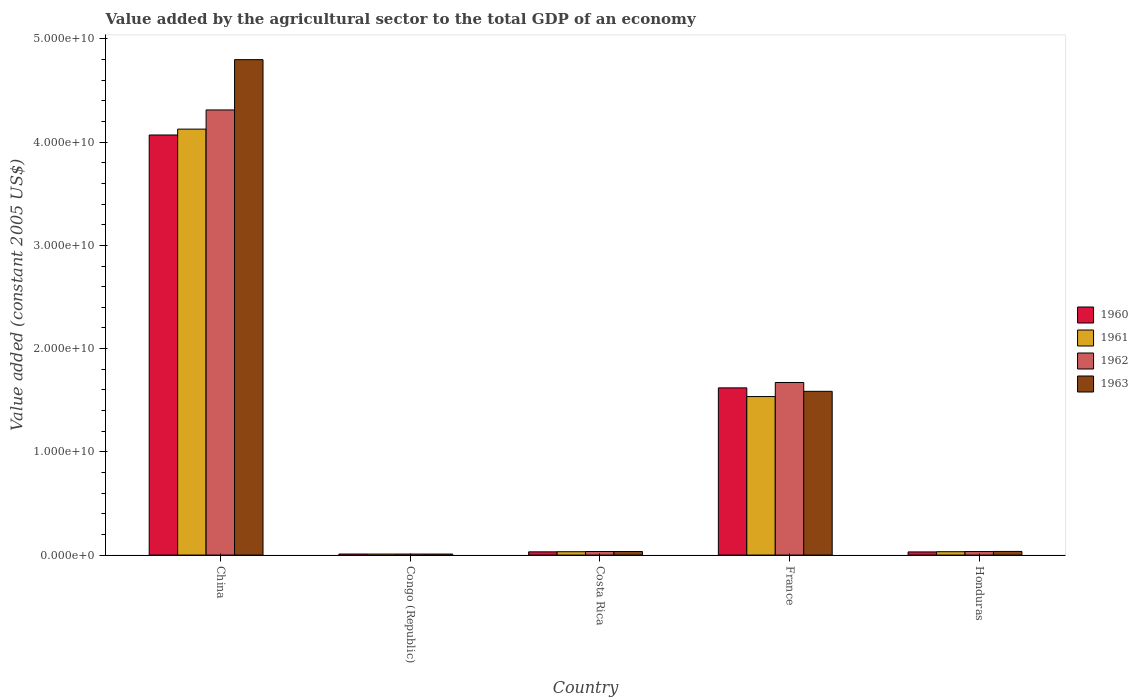How many groups of bars are there?
Offer a very short reply. 5. Are the number of bars per tick equal to the number of legend labels?
Make the answer very short. Yes. How many bars are there on the 1st tick from the left?
Your answer should be very brief. 4. What is the value added by the agricultural sector in 1963 in China?
Make the answer very short. 4.80e+1. Across all countries, what is the maximum value added by the agricultural sector in 1963?
Offer a very short reply. 4.80e+1. Across all countries, what is the minimum value added by the agricultural sector in 1960?
Provide a short and direct response. 1.01e+08. In which country was the value added by the agricultural sector in 1960 maximum?
Offer a terse response. China. In which country was the value added by the agricultural sector in 1960 minimum?
Your answer should be very brief. Congo (Republic). What is the total value added by the agricultural sector in 1961 in the graph?
Provide a short and direct response. 5.74e+1. What is the difference between the value added by the agricultural sector in 1963 in China and that in Honduras?
Your response must be concise. 4.76e+1. What is the difference between the value added by the agricultural sector in 1963 in France and the value added by the agricultural sector in 1960 in China?
Provide a short and direct response. -2.48e+1. What is the average value added by the agricultural sector in 1960 per country?
Your answer should be very brief. 1.15e+1. What is the difference between the value added by the agricultural sector of/in 1963 and value added by the agricultural sector of/in 1962 in Congo (Republic)?
Provide a short and direct response. 6.85e+05. What is the ratio of the value added by the agricultural sector in 1962 in Costa Rica to that in Honduras?
Keep it short and to the point. 1.01. What is the difference between the highest and the second highest value added by the agricultural sector in 1963?
Your answer should be very brief. 4.76e+1. What is the difference between the highest and the lowest value added by the agricultural sector in 1961?
Provide a succinct answer. 4.12e+1. Is it the case that in every country, the sum of the value added by the agricultural sector in 1960 and value added by the agricultural sector in 1963 is greater than the sum of value added by the agricultural sector in 1961 and value added by the agricultural sector in 1962?
Your answer should be very brief. No. What does the 1st bar from the left in Costa Rica represents?
Provide a short and direct response. 1960. How many bars are there?
Offer a terse response. 20. Are all the bars in the graph horizontal?
Your response must be concise. No. How many countries are there in the graph?
Your response must be concise. 5. What is the difference between two consecutive major ticks on the Y-axis?
Offer a terse response. 1.00e+1. Does the graph contain any zero values?
Your answer should be compact. No. Does the graph contain grids?
Ensure brevity in your answer.  No. Where does the legend appear in the graph?
Offer a very short reply. Center right. What is the title of the graph?
Keep it short and to the point. Value added by the agricultural sector to the total GDP of an economy. Does "1978" appear as one of the legend labels in the graph?
Give a very brief answer. No. What is the label or title of the X-axis?
Ensure brevity in your answer.  Country. What is the label or title of the Y-axis?
Offer a terse response. Value added (constant 2005 US$). What is the Value added (constant 2005 US$) in 1960 in China?
Offer a very short reply. 4.07e+1. What is the Value added (constant 2005 US$) of 1961 in China?
Offer a very short reply. 4.13e+1. What is the Value added (constant 2005 US$) in 1962 in China?
Give a very brief answer. 4.31e+1. What is the Value added (constant 2005 US$) of 1963 in China?
Provide a succinct answer. 4.80e+1. What is the Value added (constant 2005 US$) of 1960 in Congo (Republic)?
Your response must be concise. 1.01e+08. What is the Value added (constant 2005 US$) of 1961 in Congo (Republic)?
Give a very brief answer. 9.74e+07. What is the Value added (constant 2005 US$) in 1962 in Congo (Republic)?
Keep it short and to the point. 9.79e+07. What is the Value added (constant 2005 US$) in 1963 in Congo (Republic)?
Your response must be concise. 9.86e+07. What is the Value added (constant 2005 US$) of 1960 in Costa Rica?
Provide a short and direct response. 3.13e+08. What is the Value added (constant 2005 US$) of 1961 in Costa Rica?
Offer a very short reply. 3.24e+08. What is the Value added (constant 2005 US$) of 1962 in Costa Rica?
Provide a succinct answer. 3.44e+08. What is the Value added (constant 2005 US$) of 1963 in Costa Rica?
Offer a terse response. 3.43e+08. What is the Value added (constant 2005 US$) of 1960 in France?
Your answer should be very brief. 1.62e+1. What is the Value added (constant 2005 US$) in 1961 in France?
Provide a succinct answer. 1.54e+1. What is the Value added (constant 2005 US$) in 1962 in France?
Provide a short and direct response. 1.67e+1. What is the Value added (constant 2005 US$) of 1963 in France?
Your response must be concise. 1.59e+1. What is the Value added (constant 2005 US$) of 1960 in Honduras?
Provide a short and direct response. 3.05e+08. What is the Value added (constant 2005 US$) in 1961 in Honduras?
Provide a succinct answer. 3.25e+08. What is the Value added (constant 2005 US$) in 1962 in Honduras?
Provide a succinct answer. 3.41e+08. What is the Value added (constant 2005 US$) in 1963 in Honduras?
Your answer should be compact. 3.53e+08. Across all countries, what is the maximum Value added (constant 2005 US$) in 1960?
Provide a short and direct response. 4.07e+1. Across all countries, what is the maximum Value added (constant 2005 US$) of 1961?
Offer a very short reply. 4.13e+1. Across all countries, what is the maximum Value added (constant 2005 US$) of 1962?
Offer a terse response. 4.31e+1. Across all countries, what is the maximum Value added (constant 2005 US$) of 1963?
Give a very brief answer. 4.80e+1. Across all countries, what is the minimum Value added (constant 2005 US$) in 1960?
Your response must be concise. 1.01e+08. Across all countries, what is the minimum Value added (constant 2005 US$) of 1961?
Give a very brief answer. 9.74e+07. Across all countries, what is the minimum Value added (constant 2005 US$) in 1962?
Offer a very short reply. 9.79e+07. Across all countries, what is the minimum Value added (constant 2005 US$) of 1963?
Your answer should be compact. 9.86e+07. What is the total Value added (constant 2005 US$) of 1960 in the graph?
Your answer should be very brief. 5.76e+1. What is the total Value added (constant 2005 US$) of 1961 in the graph?
Your response must be concise. 5.74e+1. What is the total Value added (constant 2005 US$) in 1962 in the graph?
Your answer should be very brief. 6.06e+1. What is the total Value added (constant 2005 US$) of 1963 in the graph?
Give a very brief answer. 6.47e+1. What is the difference between the Value added (constant 2005 US$) of 1960 in China and that in Congo (Republic)?
Ensure brevity in your answer.  4.06e+1. What is the difference between the Value added (constant 2005 US$) of 1961 in China and that in Congo (Republic)?
Your response must be concise. 4.12e+1. What is the difference between the Value added (constant 2005 US$) of 1962 in China and that in Congo (Republic)?
Give a very brief answer. 4.30e+1. What is the difference between the Value added (constant 2005 US$) in 1963 in China and that in Congo (Republic)?
Your answer should be compact. 4.79e+1. What is the difference between the Value added (constant 2005 US$) in 1960 in China and that in Costa Rica?
Offer a terse response. 4.04e+1. What is the difference between the Value added (constant 2005 US$) in 1961 in China and that in Costa Rica?
Your response must be concise. 4.09e+1. What is the difference between the Value added (constant 2005 US$) of 1962 in China and that in Costa Rica?
Make the answer very short. 4.28e+1. What is the difference between the Value added (constant 2005 US$) in 1963 in China and that in Costa Rica?
Your answer should be compact. 4.77e+1. What is the difference between the Value added (constant 2005 US$) of 1960 in China and that in France?
Provide a succinct answer. 2.45e+1. What is the difference between the Value added (constant 2005 US$) of 1961 in China and that in France?
Ensure brevity in your answer.  2.59e+1. What is the difference between the Value added (constant 2005 US$) of 1962 in China and that in France?
Make the answer very short. 2.64e+1. What is the difference between the Value added (constant 2005 US$) of 1963 in China and that in France?
Your response must be concise. 3.21e+1. What is the difference between the Value added (constant 2005 US$) in 1960 in China and that in Honduras?
Your response must be concise. 4.04e+1. What is the difference between the Value added (constant 2005 US$) of 1961 in China and that in Honduras?
Keep it short and to the point. 4.09e+1. What is the difference between the Value added (constant 2005 US$) in 1962 in China and that in Honduras?
Ensure brevity in your answer.  4.28e+1. What is the difference between the Value added (constant 2005 US$) of 1963 in China and that in Honduras?
Your response must be concise. 4.76e+1. What is the difference between the Value added (constant 2005 US$) in 1960 in Congo (Republic) and that in Costa Rica?
Your answer should be very brief. -2.12e+08. What is the difference between the Value added (constant 2005 US$) in 1961 in Congo (Republic) and that in Costa Rica?
Provide a succinct answer. -2.27e+08. What is the difference between the Value added (constant 2005 US$) in 1962 in Congo (Republic) and that in Costa Rica?
Make the answer very short. -2.46e+08. What is the difference between the Value added (constant 2005 US$) of 1963 in Congo (Republic) and that in Costa Rica?
Make the answer very short. -2.45e+08. What is the difference between the Value added (constant 2005 US$) in 1960 in Congo (Republic) and that in France?
Give a very brief answer. -1.61e+1. What is the difference between the Value added (constant 2005 US$) of 1961 in Congo (Republic) and that in France?
Your answer should be very brief. -1.53e+1. What is the difference between the Value added (constant 2005 US$) in 1962 in Congo (Republic) and that in France?
Ensure brevity in your answer.  -1.66e+1. What is the difference between the Value added (constant 2005 US$) of 1963 in Congo (Republic) and that in France?
Offer a terse response. -1.58e+1. What is the difference between the Value added (constant 2005 US$) in 1960 in Congo (Republic) and that in Honduras?
Ensure brevity in your answer.  -2.04e+08. What is the difference between the Value added (constant 2005 US$) in 1961 in Congo (Republic) and that in Honduras?
Offer a very short reply. -2.28e+08. What is the difference between the Value added (constant 2005 US$) of 1962 in Congo (Republic) and that in Honduras?
Your answer should be compact. -2.43e+08. What is the difference between the Value added (constant 2005 US$) of 1963 in Congo (Republic) and that in Honduras?
Give a very brief answer. -2.55e+08. What is the difference between the Value added (constant 2005 US$) in 1960 in Costa Rica and that in France?
Provide a short and direct response. -1.59e+1. What is the difference between the Value added (constant 2005 US$) of 1961 in Costa Rica and that in France?
Ensure brevity in your answer.  -1.50e+1. What is the difference between the Value added (constant 2005 US$) in 1962 in Costa Rica and that in France?
Ensure brevity in your answer.  -1.64e+1. What is the difference between the Value added (constant 2005 US$) of 1963 in Costa Rica and that in France?
Your answer should be compact. -1.55e+1. What is the difference between the Value added (constant 2005 US$) in 1960 in Costa Rica and that in Honduras?
Give a very brief answer. 7.61e+06. What is the difference between the Value added (constant 2005 US$) in 1961 in Costa Rica and that in Honduras?
Keep it short and to the point. -8.14e+05. What is the difference between the Value added (constant 2005 US$) of 1962 in Costa Rica and that in Honduras?
Provide a succinct answer. 3.61e+06. What is the difference between the Value added (constant 2005 US$) of 1963 in Costa Rica and that in Honduras?
Your answer should be very brief. -9.78e+06. What is the difference between the Value added (constant 2005 US$) of 1960 in France and that in Honduras?
Offer a terse response. 1.59e+1. What is the difference between the Value added (constant 2005 US$) in 1961 in France and that in Honduras?
Your answer should be very brief. 1.50e+1. What is the difference between the Value added (constant 2005 US$) of 1962 in France and that in Honduras?
Offer a terse response. 1.64e+1. What is the difference between the Value added (constant 2005 US$) of 1963 in France and that in Honduras?
Make the answer very short. 1.55e+1. What is the difference between the Value added (constant 2005 US$) of 1960 in China and the Value added (constant 2005 US$) of 1961 in Congo (Republic)?
Ensure brevity in your answer.  4.06e+1. What is the difference between the Value added (constant 2005 US$) of 1960 in China and the Value added (constant 2005 US$) of 1962 in Congo (Republic)?
Provide a short and direct response. 4.06e+1. What is the difference between the Value added (constant 2005 US$) in 1960 in China and the Value added (constant 2005 US$) in 1963 in Congo (Republic)?
Keep it short and to the point. 4.06e+1. What is the difference between the Value added (constant 2005 US$) in 1961 in China and the Value added (constant 2005 US$) in 1962 in Congo (Republic)?
Offer a terse response. 4.12e+1. What is the difference between the Value added (constant 2005 US$) of 1961 in China and the Value added (constant 2005 US$) of 1963 in Congo (Republic)?
Offer a terse response. 4.12e+1. What is the difference between the Value added (constant 2005 US$) in 1962 in China and the Value added (constant 2005 US$) in 1963 in Congo (Republic)?
Give a very brief answer. 4.30e+1. What is the difference between the Value added (constant 2005 US$) in 1960 in China and the Value added (constant 2005 US$) in 1961 in Costa Rica?
Your answer should be very brief. 4.04e+1. What is the difference between the Value added (constant 2005 US$) of 1960 in China and the Value added (constant 2005 US$) of 1962 in Costa Rica?
Keep it short and to the point. 4.04e+1. What is the difference between the Value added (constant 2005 US$) of 1960 in China and the Value added (constant 2005 US$) of 1963 in Costa Rica?
Give a very brief answer. 4.04e+1. What is the difference between the Value added (constant 2005 US$) of 1961 in China and the Value added (constant 2005 US$) of 1962 in Costa Rica?
Offer a very short reply. 4.09e+1. What is the difference between the Value added (constant 2005 US$) in 1961 in China and the Value added (constant 2005 US$) in 1963 in Costa Rica?
Your response must be concise. 4.09e+1. What is the difference between the Value added (constant 2005 US$) in 1962 in China and the Value added (constant 2005 US$) in 1963 in Costa Rica?
Make the answer very short. 4.28e+1. What is the difference between the Value added (constant 2005 US$) of 1960 in China and the Value added (constant 2005 US$) of 1961 in France?
Your response must be concise. 2.53e+1. What is the difference between the Value added (constant 2005 US$) in 1960 in China and the Value added (constant 2005 US$) in 1962 in France?
Your answer should be compact. 2.40e+1. What is the difference between the Value added (constant 2005 US$) of 1960 in China and the Value added (constant 2005 US$) of 1963 in France?
Your response must be concise. 2.48e+1. What is the difference between the Value added (constant 2005 US$) in 1961 in China and the Value added (constant 2005 US$) in 1962 in France?
Provide a succinct answer. 2.45e+1. What is the difference between the Value added (constant 2005 US$) in 1961 in China and the Value added (constant 2005 US$) in 1963 in France?
Make the answer very short. 2.54e+1. What is the difference between the Value added (constant 2005 US$) in 1962 in China and the Value added (constant 2005 US$) in 1963 in France?
Provide a succinct answer. 2.73e+1. What is the difference between the Value added (constant 2005 US$) of 1960 in China and the Value added (constant 2005 US$) of 1961 in Honduras?
Offer a terse response. 4.04e+1. What is the difference between the Value added (constant 2005 US$) of 1960 in China and the Value added (constant 2005 US$) of 1962 in Honduras?
Make the answer very short. 4.04e+1. What is the difference between the Value added (constant 2005 US$) of 1960 in China and the Value added (constant 2005 US$) of 1963 in Honduras?
Offer a terse response. 4.03e+1. What is the difference between the Value added (constant 2005 US$) of 1961 in China and the Value added (constant 2005 US$) of 1962 in Honduras?
Your response must be concise. 4.09e+1. What is the difference between the Value added (constant 2005 US$) of 1961 in China and the Value added (constant 2005 US$) of 1963 in Honduras?
Provide a succinct answer. 4.09e+1. What is the difference between the Value added (constant 2005 US$) in 1962 in China and the Value added (constant 2005 US$) in 1963 in Honduras?
Your answer should be compact. 4.28e+1. What is the difference between the Value added (constant 2005 US$) of 1960 in Congo (Republic) and the Value added (constant 2005 US$) of 1961 in Costa Rica?
Your response must be concise. -2.24e+08. What is the difference between the Value added (constant 2005 US$) in 1960 in Congo (Republic) and the Value added (constant 2005 US$) in 1962 in Costa Rica?
Provide a short and direct response. -2.43e+08. What is the difference between the Value added (constant 2005 US$) of 1960 in Congo (Republic) and the Value added (constant 2005 US$) of 1963 in Costa Rica?
Your response must be concise. -2.42e+08. What is the difference between the Value added (constant 2005 US$) in 1961 in Congo (Republic) and the Value added (constant 2005 US$) in 1962 in Costa Rica?
Ensure brevity in your answer.  -2.47e+08. What is the difference between the Value added (constant 2005 US$) in 1961 in Congo (Republic) and the Value added (constant 2005 US$) in 1963 in Costa Rica?
Make the answer very short. -2.46e+08. What is the difference between the Value added (constant 2005 US$) of 1962 in Congo (Republic) and the Value added (constant 2005 US$) of 1963 in Costa Rica?
Your response must be concise. -2.45e+08. What is the difference between the Value added (constant 2005 US$) of 1960 in Congo (Republic) and the Value added (constant 2005 US$) of 1961 in France?
Offer a terse response. -1.53e+1. What is the difference between the Value added (constant 2005 US$) in 1960 in Congo (Republic) and the Value added (constant 2005 US$) in 1962 in France?
Keep it short and to the point. -1.66e+1. What is the difference between the Value added (constant 2005 US$) in 1960 in Congo (Republic) and the Value added (constant 2005 US$) in 1963 in France?
Give a very brief answer. -1.58e+1. What is the difference between the Value added (constant 2005 US$) of 1961 in Congo (Republic) and the Value added (constant 2005 US$) of 1962 in France?
Keep it short and to the point. -1.66e+1. What is the difference between the Value added (constant 2005 US$) of 1961 in Congo (Republic) and the Value added (constant 2005 US$) of 1963 in France?
Your answer should be very brief. -1.58e+1. What is the difference between the Value added (constant 2005 US$) of 1962 in Congo (Republic) and the Value added (constant 2005 US$) of 1963 in France?
Your answer should be very brief. -1.58e+1. What is the difference between the Value added (constant 2005 US$) in 1960 in Congo (Republic) and the Value added (constant 2005 US$) in 1961 in Honduras?
Give a very brief answer. -2.24e+08. What is the difference between the Value added (constant 2005 US$) of 1960 in Congo (Republic) and the Value added (constant 2005 US$) of 1962 in Honduras?
Your response must be concise. -2.40e+08. What is the difference between the Value added (constant 2005 US$) of 1960 in Congo (Republic) and the Value added (constant 2005 US$) of 1963 in Honduras?
Offer a terse response. -2.52e+08. What is the difference between the Value added (constant 2005 US$) of 1961 in Congo (Republic) and the Value added (constant 2005 US$) of 1962 in Honduras?
Make the answer very short. -2.43e+08. What is the difference between the Value added (constant 2005 US$) in 1961 in Congo (Republic) and the Value added (constant 2005 US$) in 1963 in Honduras?
Make the answer very short. -2.56e+08. What is the difference between the Value added (constant 2005 US$) of 1962 in Congo (Republic) and the Value added (constant 2005 US$) of 1963 in Honduras?
Ensure brevity in your answer.  -2.55e+08. What is the difference between the Value added (constant 2005 US$) in 1960 in Costa Rica and the Value added (constant 2005 US$) in 1961 in France?
Your response must be concise. -1.50e+1. What is the difference between the Value added (constant 2005 US$) of 1960 in Costa Rica and the Value added (constant 2005 US$) of 1962 in France?
Keep it short and to the point. -1.64e+1. What is the difference between the Value added (constant 2005 US$) in 1960 in Costa Rica and the Value added (constant 2005 US$) in 1963 in France?
Your response must be concise. -1.56e+1. What is the difference between the Value added (constant 2005 US$) in 1961 in Costa Rica and the Value added (constant 2005 US$) in 1962 in France?
Offer a very short reply. -1.64e+1. What is the difference between the Value added (constant 2005 US$) in 1961 in Costa Rica and the Value added (constant 2005 US$) in 1963 in France?
Ensure brevity in your answer.  -1.55e+1. What is the difference between the Value added (constant 2005 US$) of 1962 in Costa Rica and the Value added (constant 2005 US$) of 1963 in France?
Your answer should be compact. -1.55e+1. What is the difference between the Value added (constant 2005 US$) in 1960 in Costa Rica and the Value added (constant 2005 US$) in 1961 in Honduras?
Keep it short and to the point. -1.23e+07. What is the difference between the Value added (constant 2005 US$) of 1960 in Costa Rica and the Value added (constant 2005 US$) of 1962 in Honduras?
Provide a short and direct response. -2.78e+07. What is the difference between the Value added (constant 2005 US$) in 1960 in Costa Rica and the Value added (constant 2005 US$) in 1963 in Honduras?
Your answer should be very brief. -4.02e+07. What is the difference between the Value added (constant 2005 US$) of 1961 in Costa Rica and the Value added (constant 2005 US$) of 1962 in Honduras?
Give a very brief answer. -1.63e+07. What is the difference between the Value added (constant 2005 US$) of 1961 in Costa Rica and the Value added (constant 2005 US$) of 1963 in Honduras?
Ensure brevity in your answer.  -2.87e+07. What is the difference between the Value added (constant 2005 US$) in 1962 in Costa Rica and the Value added (constant 2005 US$) in 1963 in Honduras?
Offer a terse response. -8.78e+06. What is the difference between the Value added (constant 2005 US$) of 1960 in France and the Value added (constant 2005 US$) of 1961 in Honduras?
Provide a short and direct response. 1.59e+1. What is the difference between the Value added (constant 2005 US$) of 1960 in France and the Value added (constant 2005 US$) of 1962 in Honduras?
Offer a terse response. 1.59e+1. What is the difference between the Value added (constant 2005 US$) in 1960 in France and the Value added (constant 2005 US$) in 1963 in Honduras?
Ensure brevity in your answer.  1.58e+1. What is the difference between the Value added (constant 2005 US$) in 1961 in France and the Value added (constant 2005 US$) in 1962 in Honduras?
Your response must be concise. 1.50e+1. What is the difference between the Value added (constant 2005 US$) of 1961 in France and the Value added (constant 2005 US$) of 1963 in Honduras?
Keep it short and to the point. 1.50e+1. What is the difference between the Value added (constant 2005 US$) in 1962 in France and the Value added (constant 2005 US$) in 1963 in Honduras?
Provide a succinct answer. 1.64e+1. What is the average Value added (constant 2005 US$) of 1960 per country?
Ensure brevity in your answer.  1.15e+1. What is the average Value added (constant 2005 US$) in 1961 per country?
Make the answer very short. 1.15e+1. What is the average Value added (constant 2005 US$) of 1962 per country?
Make the answer very short. 1.21e+1. What is the average Value added (constant 2005 US$) of 1963 per country?
Your answer should be compact. 1.29e+1. What is the difference between the Value added (constant 2005 US$) in 1960 and Value added (constant 2005 US$) in 1961 in China?
Ensure brevity in your answer.  -5.70e+08. What is the difference between the Value added (constant 2005 US$) in 1960 and Value added (constant 2005 US$) in 1962 in China?
Give a very brief answer. -2.43e+09. What is the difference between the Value added (constant 2005 US$) of 1960 and Value added (constant 2005 US$) of 1963 in China?
Provide a short and direct response. -7.30e+09. What is the difference between the Value added (constant 2005 US$) in 1961 and Value added (constant 2005 US$) in 1962 in China?
Provide a short and direct response. -1.86e+09. What is the difference between the Value added (constant 2005 US$) in 1961 and Value added (constant 2005 US$) in 1963 in China?
Make the answer very short. -6.73e+09. What is the difference between the Value added (constant 2005 US$) in 1962 and Value added (constant 2005 US$) in 1963 in China?
Keep it short and to the point. -4.87e+09. What is the difference between the Value added (constant 2005 US$) in 1960 and Value added (constant 2005 US$) in 1961 in Congo (Republic)?
Your response must be concise. 3.61e+06. What is the difference between the Value added (constant 2005 US$) in 1960 and Value added (constant 2005 US$) in 1962 in Congo (Republic)?
Provide a short and direct response. 3.02e+06. What is the difference between the Value added (constant 2005 US$) of 1960 and Value added (constant 2005 US$) of 1963 in Congo (Republic)?
Provide a short and direct response. 2.34e+06. What is the difference between the Value added (constant 2005 US$) of 1961 and Value added (constant 2005 US$) of 1962 in Congo (Republic)?
Your answer should be very brief. -5.86e+05. What is the difference between the Value added (constant 2005 US$) of 1961 and Value added (constant 2005 US$) of 1963 in Congo (Republic)?
Offer a terse response. -1.27e+06. What is the difference between the Value added (constant 2005 US$) of 1962 and Value added (constant 2005 US$) of 1963 in Congo (Republic)?
Your response must be concise. -6.85e+05. What is the difference between the Value added (constant 2005 US$) of 1960 and Value added (constant 2005 US$) of 1961 in Costa Rica?
Give a very brief answer. -1.15e+07. What is the difference between the Value added (constant 2005 US$) in 1960 and Value added (constant 2005 US$) in 1962 in Costa Rica?
Ensure brevity in your answer.  -3.14e+07. What is the difference between the Value added (constant 2005 US$) of 1960 and Value added (constant 2005 US$) of 1963 in Costa Rica?
Give a very brief answer. -3.04e+07. What is the difference between the Value added (constant 2005 US$) of 1961 and Value added (constant 2005 US$) of 1962 in Costa Rica?
Ensure brevity in your answer.  -1.99e+07. What is the difference between the Value added (constant 2005 US$) of 1961 and Value added (constant 2005 US$) of 1963 in Costa Rica?
Offer a terse response. -1.89e+07. What is the difference between the Value added (constant 2005 US$) of 1962 and Value added (constant 2005 US$) of 1963 in Costa Rica?
Ensure brevity in your answer.  1.00e+06. What is the difference between the Value added (constant 2005 US$) in 1960 and Value added (constant 2005 US$) in 1961 in France?
Give a very brief answer. 8.42e+08. What is the difference between the Value added (constant 2005 US$) in 1960 and Value added (constant 2005 US$) in 1962 in France?
Provide a succinct answer. -5.20e+08. What is the difference between the Value added (constant 2005 US$) in 1960 and Value added (constant 2005 US$) in 1963 in France?
Provide a succinct answer. 3.35e+08. What is the difference between the Value added (constant 2005 US$) in 1961 and Value added (constant 2005 US$) in 1962 in France?
Make the answer very short. -1.36e+09. What is the difference between the Value added (constant 2005 US$) in 1961 and Value added (constant 2005 US$) in 1963 in France?
Give a very brief answer. -5.07e+08. What is the difference between the Value added (constant 2005 US$) of 1962 and Value added (constant 2005 US$) of 1963 in France?
Provide a short and direct response. 8.56e+08. What is the difference between the Value added (constant 2005 US$) in 1960 and Value added (constant 2005 US$) in 1961 in Honduras?
Your response must be concise. -1.99e+07. What is the difference between the Value added (constant 2005 US$) of 1960 and Value added (constant 2005 US$) of 1962 in Honduras?
Offer a terse response. -3.54e+07. What is the difference between the Value added (constant 2005 US$) in 1960 and Value added (constant 2005 US$) in 1963 in Honduras?
Keep it short and to the point. -4.78e+07. What is the difference between the Value added (constant 2005 US$) of 1961 and Value added (constant 2005 US$) of 1962 in Honduras?
Your response must be concise. -1.55e+07. What is the difference between the Value added (constant 2005 US$) of 1961 and Value added (constant 2005 US$) of 1963 in Honduras?
Provide a short and direct response. -2.79e+07. What is the difference between the Value added (constant 2005 US$) in 1962 and Value added (constant 2005 US$) in 1963 in Honduras?
Provide a short and direct response. -1.24e+07. What is the ratio of the Value added (constant 2005 US$) in 1960 in China to that in Congo (Republic)?
Your answer should be very brief. 403.12. What is the ratio of the Value added (constant 2005 US$) in 1961 in China to that in Congo (Republic)?
Offer a terse response. 423.9. What is the ratio of the Value added (constant 2005 US$) of 1962 in China to that in Congo (Republic)?
Keep it short and to the point. 440.32. What is the ratio of the Value added (constant 2005 US$) in 1963 in China to that in Congo (Republic)?
Provide a succinct answer. 486.68. What is the ratio of the Value added (constant 2005 US$) in 1960 in China to that in Costa Rica?
Give a very brief answer. 130.03. What is the ratio of the Value added (constant 2005 US$) in 1961 in China to that in Costa Rica?
Your response must be concise. 127.18. What is the ratio of the Value added (constant 2005 US$) in 1962 in China to that in Costa Rica?
Offer a terse response. 125.23. What is the ratio of the Value added (constant 2005 US$) of 1963 in China to that in Costa Rica?
Your answer should be compact. 139.78. What is the ratio of the Value added (constant 2005 US$) in 1960 in China to that in France?
Your answer should be compact. 2.51. What is the ratio of the Value added (constant 2005 US$) in 1961 in China to that in France?
Offer a very short reply. 2.69. What is the ratio of the Value added (constant 2005 US$) of 1962 in China to that in France?
Ensure brevity in your answer.  2.58. What is the ratio of the Value added (constant 2005 US$) of 1963 in China to that in France?
Offer a terse response. 3.03. What is the ratio of the Value added (constant 2005 US$) of 1960 in China to that in Honduras?
Your answer should be very brief. 133.27. What is the ratio of the Value added (constant 2005 US$) of 1961 in China to that in Honduras?
Ensure brevity in your answer.  126.86. What is the ratio of the Value added (constant 2005 US$) in 1962 in China to that in Honduras?
Provide a short and direct response. 126.55. What is the ratio of the Value added (constant 2005 US$) in 1963 in China to that in Honduras?
Provide a succinct answer. 135.91. What is the ratio of the Value added (constant 2005 US$) in 1960 in Congo (Republic) to that in Costa Rica?
Ensure brevity in your answer.  0.32. What is the ratio of the Value added (constant 2005 US$) in 1962 in Congo (Republic) to that in Costa Rica?
Make the answer very short. 0.28. What is the ratio of the Value added (constant 2005 US$) in 1963 in Congo (Republic) to that in Costa Rica?
Ensure brevity in your answer.  0.29. What is the ratio of the Value added (constant 2005 US$) in 1960 in Congo (Republic) to that in France?
Provide a short and direct response. 0.01. What is the ratio of the Value added (constant 2005 US$) of 1961 in Congo (Republic) to that in France?
Your answer should be very brief. 0.01. What is the ratio of the Value added (constant 2005 US$) in 1962 in Congo (Republic) to that in France?
Provide a succinct answer. 0.01. What is the ratio of the Value added (constant 2005 US$) of 1963 in Congo (Republic) to that in France?
Your answer should be very brief. 0.01. What is the ratio of the Value added (constant 2005 US$) in 1960 in Congo (Republic) to that in Honduras?
Your response must be concise. 0.33. What is the ratio of the Value added (constant 2005 US$) in 1961 in Congo (Republic) to that in Honduras?
Your response must be concise. 0.3. What is the ratio of the Value added (constant 2005 US$) in 1962 in Congo (Republic) to that in Honduras?
Your answer should be very brief. 0.29. What is the ratio of the Value added (constant 2005 US$) in 1963 in Congo (Republic) to that in Honduras?
Ensure brevity in your answer.  0.28. What is the ratio of the Value added (constant 2005 US$) of 1960 in Costa Rica to that in France?
Provide a succinct answer. 0.02. What is the ratio of the Value added (constant 2005 US$) of 1961 in Costa Rica to that in France?
Your answer should be very brief. 0.02. What is the ratio of the Value added (constant 2005 US$) in 1962 in Costa Rica to that in France?
Your answer should be very brief. 0.02. What is the ratio of the Value added (constant 2005 US$) in 1963 in Costa Rica to that in France?
Offer a very short reply. 0.02. What is the ratio of the Value added (constant 2005 US$) of 1960 in Costa Rica to that in Honduras?
Offer a terse response. 1.02. What is the ratio of the Value added (constant 2005 US$) in 1961 in Costa Rica to that in Honduras?
Keep it short and to the point. 1. What is the ratio of the Value added (constant 2005 US$) in 1962 in Costa Rica to that in Honduras?
Provide a short and direct response. 1.01. What is the ratio of the Value added (constant 2005 US$) of 1963 in Costa Rica to that in Honduras?
Your answer should be compact. 0.97. What is the ratio of the Value added (constant 2005 US$) of 1960 in France to that in Honduras?
Give a very brief answer. 53.05. What is the ratio of the Value added (constant 2005 US$) in 1961 in France to that in Honduras?
Keep it short and to the point. 47.21. What is the ratio of the Value added (constant 2005 US$) of 1962 in France to that in Honduras?
Offer a terse response. 49.07. What is the ratio of the Value added (constant 2005 US$) in 1963 in France to that in Honduras?
Keep it short and to the point. 44.92. What is the difference between the highest and the second highest Value added (constant 2005 US$) in 1960?
Offer a terse response. 2.45e+1. What is the difference between the highest and the second highest Value added (constant 2005 US$) of 1961?
Keep it short and to the point. 2.59e+1. What is the difference between the highest and the second highest Value added (constant 2005 US$) in 1962?
Provide a short and direct response. 2.64e+1. What is the difference between the highest and the second highest Value added (constant 2005 US$) in 1963?
Give a very brief answer. 3.21e+1. What is the difference between the highest and the lowest Value added (constant 2005 US$) in 1960?
Offer a very short reply. 4.06e+1. What is the difference between the highest and the lowest Value added (constant 2005 US$) of 1961?
Ensure brevity in your answer.  4.12e+1. What is the difference between the highest and the lowest Value added (constant 2005 US$) in 1962?
Make the answer very short. 4.30e+1. What is the difference between the highest and the lowest Value added (constant 2005 US$) of 1963?
Provide a short and direct response. 4.79e+1. 